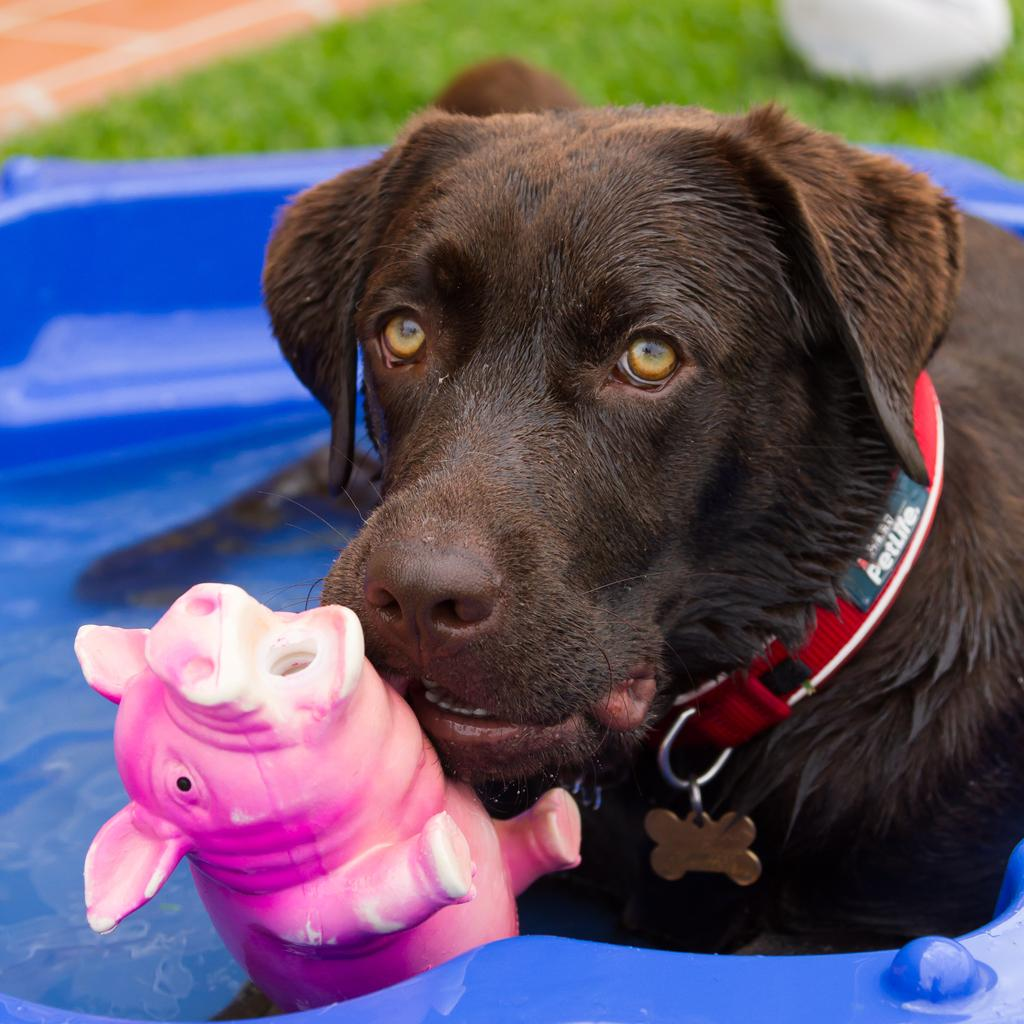What is located in the foreground of the image? There is a toy and a dog in a pet swimming pool in the foreground of the image. What type of surface is visible at the top of the image? There is grass visible at the top of the image. What is the condition of the remaining elements in the image? The remaining elements in the image are not clear. What grade does the kitty receive for its performance in the image? There is no kitty present in the image, so it cannot receive a grade for its performance. 